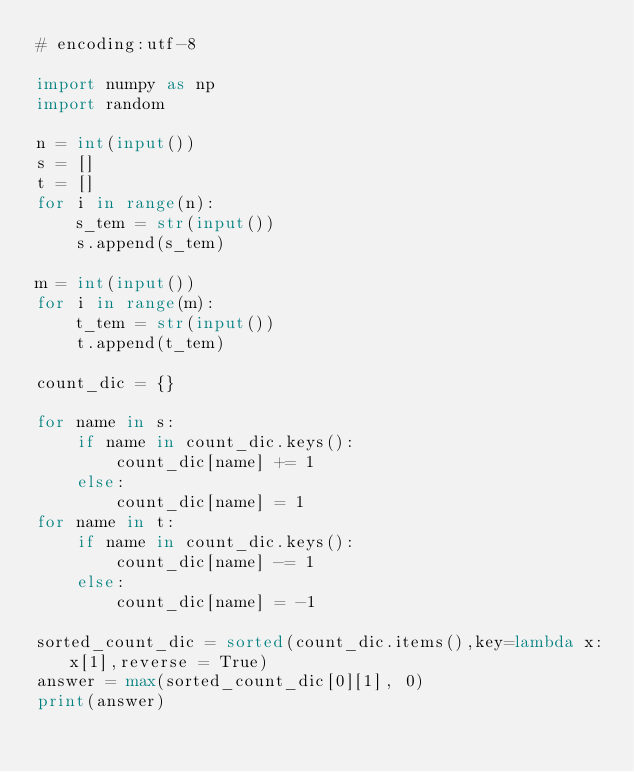Convert code to text. <code><loc_0><loc_0><loc_500><loc_500><_Python_># encoding:utf-8

import numpy as np
import random

n = int(input())
s = []
t = []
for i in range(n):
    s_tem = str(input())
    s.append(s_tem)

m = int(input())
for i in range(m):
    t_tem = str(input())
    t.append(t_tem)

count_dic = {}

for name in s:
    if name in count_dic.keys():
        count_dic[name] += 1
    else:
        count_dic[name] = 1
for name in t:
    if name in count_dic.keys():
        count_dic[name] -= 1
    else:
        count_dic[name] = -1

sorted_count_dic = sorted(count_dic.items(),key=lambda x:x[1],reverse = True)
answer = max(sorted_count_dic[0][1], 0)
print(answer)
</code> 